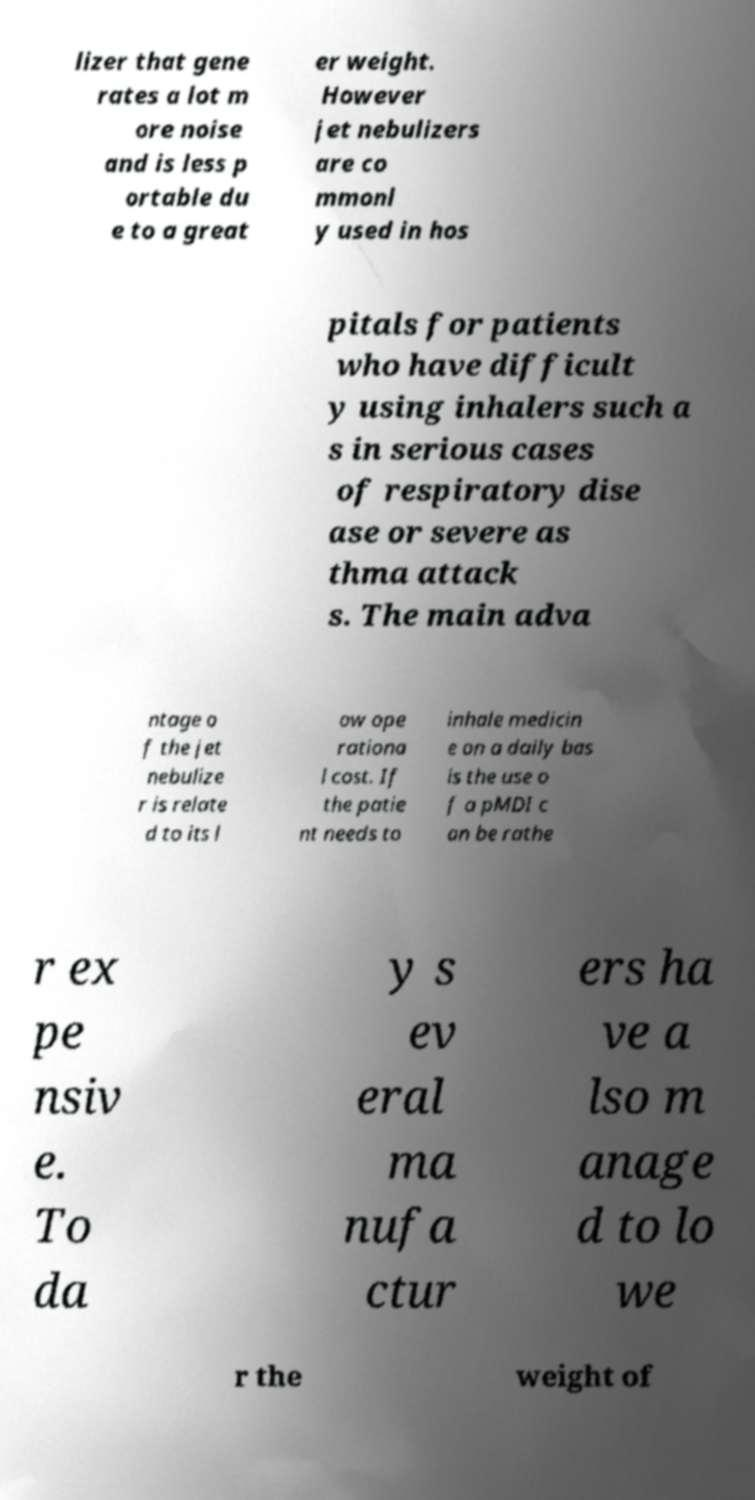I need the written content from this picture converted into text. Can you do that? lizer that gene rates a lot m ore noise and is less p ortable du e to a great er weight. However jet nebulizers are co mmonl y used in hos pitals for patients who have difficult y using inhalers such a s in serious cases of respiratory dise ase or severe as thma attack s. The main adva ntage o f the jet nebulize r is relate d to its l ow ope rationa l cost. If the patie nt needs to inhale medicin e on a daily bas is the use o f a pMDI c an be rathe r ex pe nsiv e. To da y s ev eral ma nufa ctur ers ha ve a lso m anage d to lo we r the weight of 